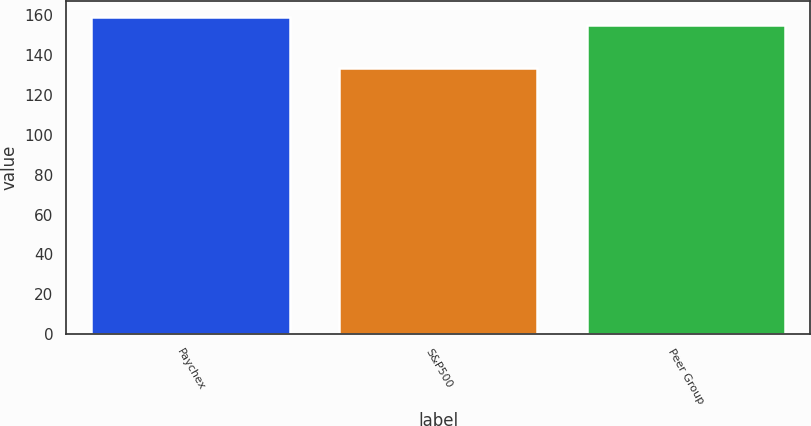<chart> <loc_0><loc_0><loc_500><loc_500><bar_chart><fcel>Paychex<fcel>S&P500<fcel>Peer Group<nl><fcel>159.07<fcel>133.59<fcel>154.93<nl></chart> 